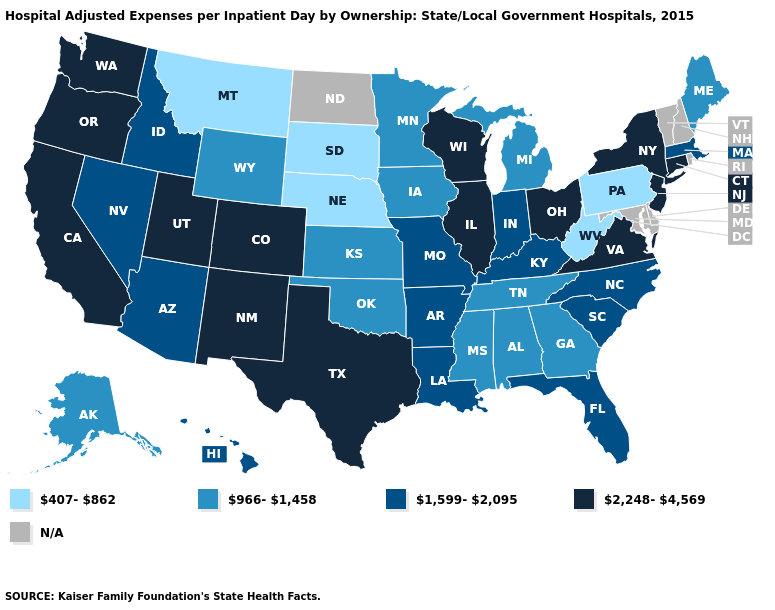What is the value of North Dakota?
Answer briefly. N/A. Does the map have missing data?
Give a very brief answer. Yes. Among the states that border Louisiana , does Arkansas have the lowest value?
Quick response, please. No. What is the value of New Hampshire?
Write a very short answer. N/A. Which states have the lowest value in the USA?
Keep it brief. Montana, Nebraska, Pennsylvania, South Dakota, West Virginia. What is the value of Montana?
Answer briefly. 407-862. Is the legend a continuous bar?
Keep it brief. No. What is the lowest value in the USA?
Be succinct. 407-862. Name the states that have a value in the range 407-862?
Be succinct. Montana, Nebraska, Pennsylvania, South Dakota, West Virginia. Name the states that have a value in the range N/A?
Give a very brief answer. Delaware, Maryland, New Hampshire, North Dakota, Rhode Island, Vermont. Name the states that have a value in the range N/A?
Short answer required. Delaware, Maryland, New Hampshire, North Dakota, Rhode Island, Vermont. Among the states that border Minnesota , which have the highest value?
Quick response, please. Wisconsin. What is the lowest value in the USA?
Give a very brief answer. 407-862. 